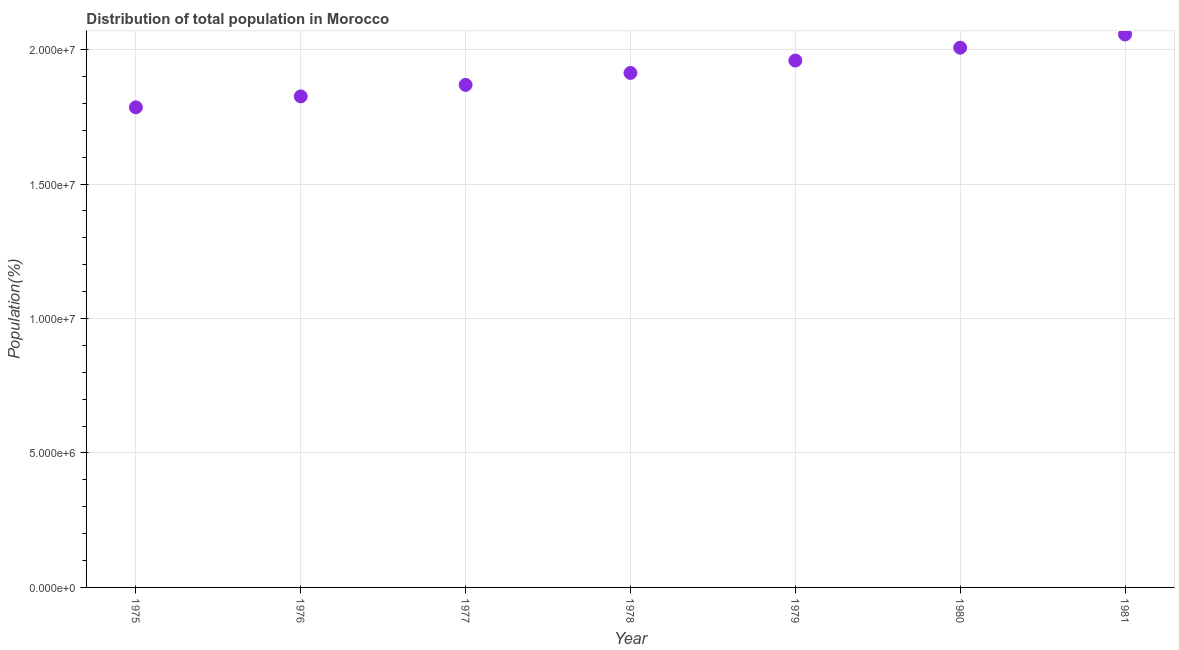What is the population in 1976?
Provide a short and direct response. 1.83e+07. Across all years, what is the maximum population?
Provide a short and direct response. 2.06e+07. Across all years, what is the minimum population?
Make the answer very short. 1.79e+07. In which year was the population maximum?
Make the answer very short. 1981. In which year was the population minimum?
Offer a terse response. 1975. What is the sum of the population?
Give a very brief answer. 1.34e+08. What is the difference between the population in 1978 and 1979?
Offer a very short reply. -4.62e+05. What is the average population per year?
Your answer should be compact. 1.92e+07. What is the median population?
Your response must be concise. 1.91e+07. In how many years, is the population greater than 10000000 %?
Provide a short and direct response. 7. What is the ratio of the population in 1976 to that in 1979?
Provide a succinct answer. 0.93. Is the population in 1977 less than that in 1978?
Offer a terse response. Yes. Is the difference between the population in 1976 and 1981 greater than the difference between any two years?
Provide a succinct answer. No. What is the difference between the highest and the second highest population?
Provide a succinct answer. 4.92e+05. What is the difference between the highest and the lowest population?
Your response must be concise. 2.71e+06. In how many years, is the population greater than the average population taken over all years?
Your answer should be compact. 3. How many years are there in the graph?
Offer a very short reply. 7. Are the values on the major ticks of Y-axis written in scientific E-notation?
Keep it short and to the point. Yes. Does the graph contain grids?
Provide a succinct answer. Yes. What is the title of the graph?
Provide a short and direct response. Distribution of total population in Morocco . What is the label or title of the X-axis?
Provide a succinct answer. Year. What is the label or title of the Y-axis?
Give a very brief answer. Population(%). What is the Population(%) in 1975?
Make the answer very short. 1.79e+07. What is the Population(%) in 1976?
Offer a very short reply. 1.83e+07. What is the Population(%) in 1977?
Give a very brief answer. 1.87e+07. What is the Population(%) in 1978?
Offer a very short reply. 1.91e+07. What is the Population(%) in 1979?
Provide a short and direct response. 1.96e+07. What is the Population(%) in 1980?
Keep it short and to the point. 2.01e+07. What is the Population(%) in 1981?
Provide a succinct answer. 2.06e+07. What is the difference between the Population(%) in 1975 and 1976?
Ensure brevity in your answer.  -4.08e+05. What is the difference between the Population(%) in 1975 and 1977?
Keep it short and to the point. -8.34e+05. What is the difference between the Population(%) in 1975 and 1978?
Keep it short and to the point. -1.28e+06. What is the difference between the Population(%) in 1975 and 1979?
Your response must be concise. -1.74e+06. What is the difference between the Population(%) in 1975 and 1980?
Ensure brevity in your answer.  -2.22e+06. What is the difference between the Population(%) in 1975 and 1981?
Provide a short and direct response. -2.71e+06. What is the difference between the Population(%) in 1976 and 1977?
Offer a very short reply. -4.26e+05. What is the difference between the Population(%) in 1976 and 1978?
Provide a short and direct response. -8.71e+05. What is the difference between the Population(%) in 1976 and 1979?
Make the answer very short. -1.33e+06. What is the difference between the Population(%) in 1976 and 1980?
Your answer should be very brief. -1.81e+06. What is the difference between the Population(%) in 1976 and 1981?
Provide a succinct answer. -2.30e+06. What is the difference between the Population(%) in 1977 and 1978?
Your answer should be compact. -4.45e+05. What is the difference between the Population(%) in 1977 and 1979?
Offer a terse response. -9.06e+05. What is the difference between the Population(%) in 1977 and 1980?
Make the answer very short. -1.38e+06. What is the difference between the Population(%) in 1977 and 1981?
Your answer should be very brief. -1.88e+06. What is the difference between the Population(%) in 1978 and 1979?
Provide a succinct answer. -4.62e+05. What is the difference between the Population(%) in 1978 and 1980?
Keep it short and to the point. -9.38e+05. What is the difference between the Population(%) in 1978 and 1981?
Provide a succinct answer. -1.43e+06. What is the difference between the Population(%) in 1979 and 1980?
Give a very brief answer. -4.77e+05. What is the difference between the Population(%) in 1979 and 1981?
Make the answer very short. -9.69e+05. What is the difference between the Population(%) in 1980 and 1981?
Provide a succinct answer. -4.92e+05. What is the ratio of the Population(%) in 1975 to that in 1976?
Offer a terse response. 0.98. What is the ratio of the Population(%) in 1975 to that in 1977?
Your answer should be compact. 0.95. What is the ratio of the Population(%) in 1975 to that in 1978?
Keep it short and to the point. 0.93. What is the ratio of the Population(%) in 1975 to that in 1979?
Your answer should be compact. 0.91. What is the ratio of the Population(%) in 1975 to that in 1980?
Your answer should be compact. 0.89. What is the ratio of the Population(%) in 1975 to that in 1981?
Give a very brief answer. 0.87. What is the ratio of the Population(%) in 1976 to that in 1978?
Keep it short and to the point. 0.95. What is the ratio of the Population(%) in 1976 to that in 1979?
Provide a short and direct response. 0.93. What is the ratio of the Population(%) in 1976 to that in 1980?
Provide a short and direct response. 0.91. What is the ratio of the Population(%) in 1976 to that in 1981?
Keep it short and to the point. 0.89. What is the ratio of the Population(%) in 1977 to that in 1978?
Offer a terse response. 0.98. What is the ratio of the Population(%) in 1977 to that in 1979?
Offer a terse response. 0.95. What is the ratio of the Population(%) in 1977 to that in 1981?
Your response must be concise. 0.91. What is the ratio of the Population(%) in 1978 to that in 1980?
Keep it short and to the point. 0.95. What is the ratio of the Population(%) in 1978 to that in 1981?
Provide a succinct answer. 0.93. What is the ratio of the Population(%) in 1979 to that in 1981?
Provide a short and direct response. 0.95. What is the ratio of the Population(%) in 1980 to that in 1981?
Offer a terse response. 0.98. 